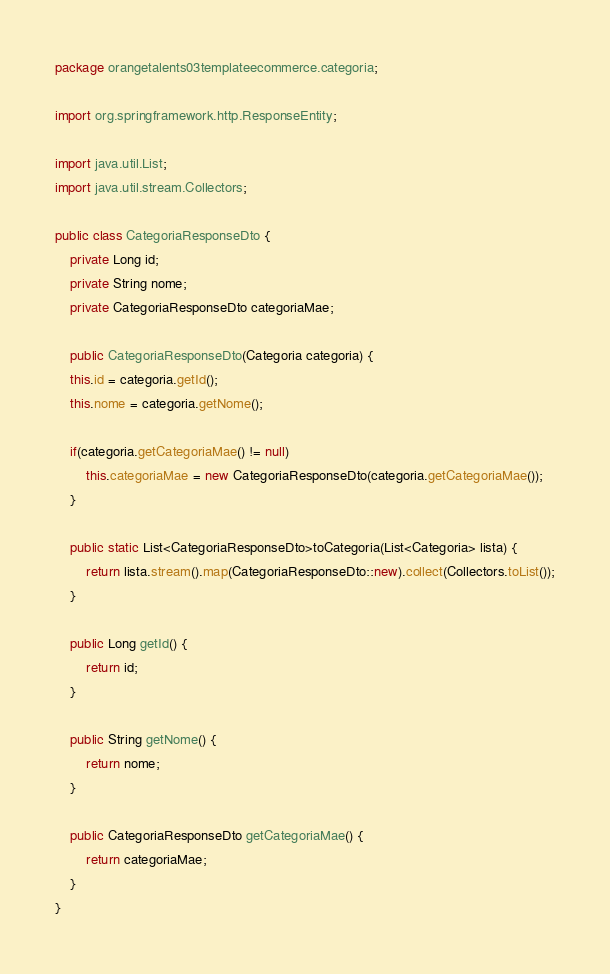<code> <loc_0><loc_0><loc_500><loc_500><_Java_>package orangetalents03templateecommerce.categoria;

import org.springframework.http.ResponseEntity;

import java.util.List;
import java.util.stream.Collectors;

public class CategoriaResponseDto {
    private Long id;
    private String nome;
    private CategoriaResponseDto categoriaMae;

    public CategoriaResponseDto(Categoria categoria) {
    this.id = categoria.getId();
    this.nome = categoria.getNome();

    if(categoria.getCategoriaMae() != null)
        this.categoriaMae = new CategoriaResponseDto(categoria.getCategoriaMae());
    }

    public static List<CategoriaResponseDto>toCategoria(List<Categoria> lista) {
        return lista.stream().map(CategoriaResponseDto::new).collect(Collectors.toList());
    }

    public Long getId() {
        return id;
    }

    public String getNome() {
        return nome;
    }

    public CategoriaResponseDto getCategoriaMae() {
        return categoriaMae;
    }
}
</code> 